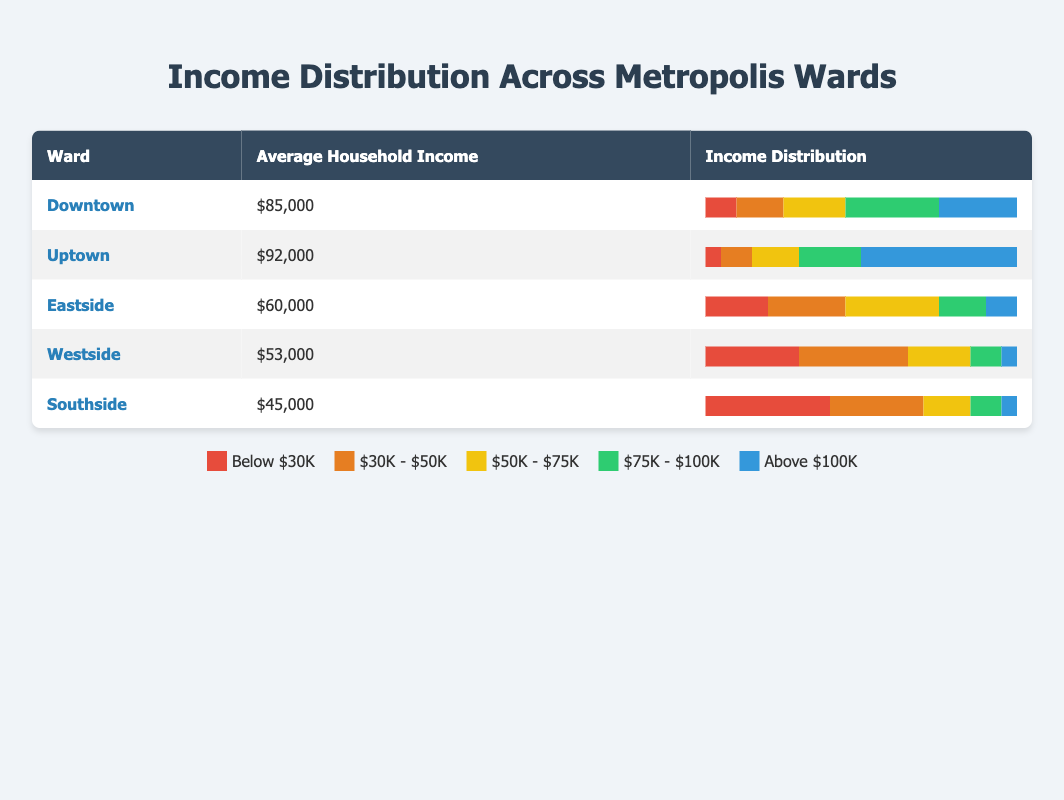What is the average household income in Uptown? The table indicates that the average household income in Uptown is $92,000, which can be found directly under the respective ward in the income column.
Answer: $92,000 Which ward has the lowest average household income? By checking the average household income column for all wards in the table, Westside has the lowest average income of $53,000.
Answer: Westside How many wards have an average household income above $80,000? Reviewing the average household incomes, Downtown ($85,000), Uptown ($92,000), and there are 2 wards total with incomes over $80,000 (Downtown and Uptown).
Answer: 2 What percentage of households in Southside earn below $30,000? The income distribution for Southside shows that 40% of households earn below $30,000. This figure is taken directly from the income distribution segment of Southside in the table.
Answer: 40% True or False: More than 50% of households in Eastside earn below $75,000. Summing the percentages for Eastside, we have 20% earning below $30K, 25% earning $30K-$50K, and 30% earning $50K-$75K, which totals 75%. Therefore, this statement is true.
Answer: True Which ward has the highest percentage of households earning between $75,000 and $100,000? Checking the income distribution for each ward, Downtown has the highest percentage of 30% of households earning between $75,000 and $100,000.
Answer: Downtown What is the average household income across all wards? To find the average household income, add the incomes of all wards (85,000 + 92,000 + 60,000 + 53,000 + 45,000) for a total of 335,000, then divide by 5 (the number of wards), resulting in an average of $67,000.
Answer: $67,000 How many wards have less than 20% of households earning above $100,000? Observing the income distributions, Southside (5%), Westside (5%), and Eastside (10%) have less than 20%, totaling 3 wards with this condition.
Answer: 3 Is the income distribution for Westside skewed towards lower incomes? Analyzing Westside's income distribution, it shows 30% below $30K and 35% from $30K-$50K, indicating a majority earn lower incomes. Thus, it can be concluded that Westside's income distribution is indeed skewed towards lower incomes.
Answer: Yes 